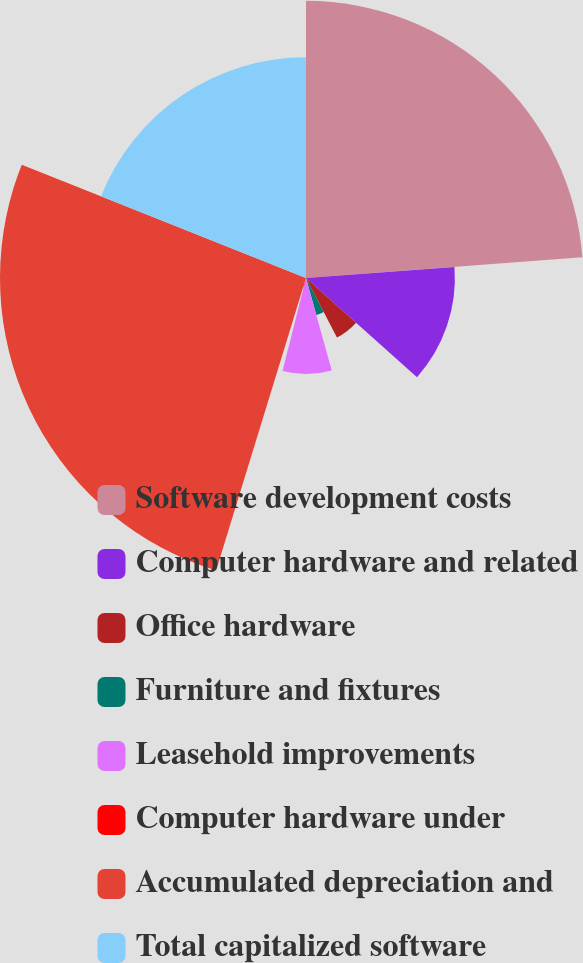<chart> <loc_0><loc_0><loc_500><loc_500><pie_chart><fcel>Software development costs<fcel>Computer hardware and related<fcel>Office hardware<fcel>Furniture and fixtures<fcel>Leasehold improvements<fcel>Computer hardware under<fcel>Accumulated depreciation and<fcel>Total capitalized software<nl><fcel>23.81%<fcel>12.79%<fcel>5.77%<fcel>3.3%<fcel>8.25%<fcel>0.82%<fcel>26.29%<fcel>18.96%<nl></chart> 